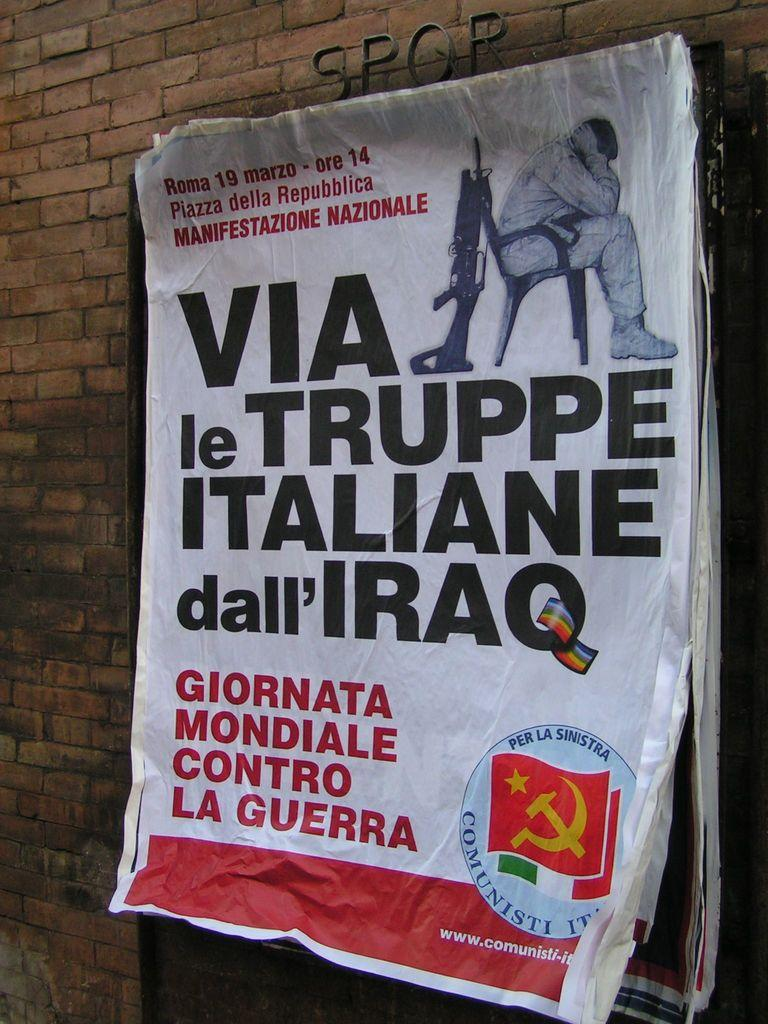<image>
Create a compact narrative representing the image presented. A poster involving Italians in Iraq hangs on a brick wall. 